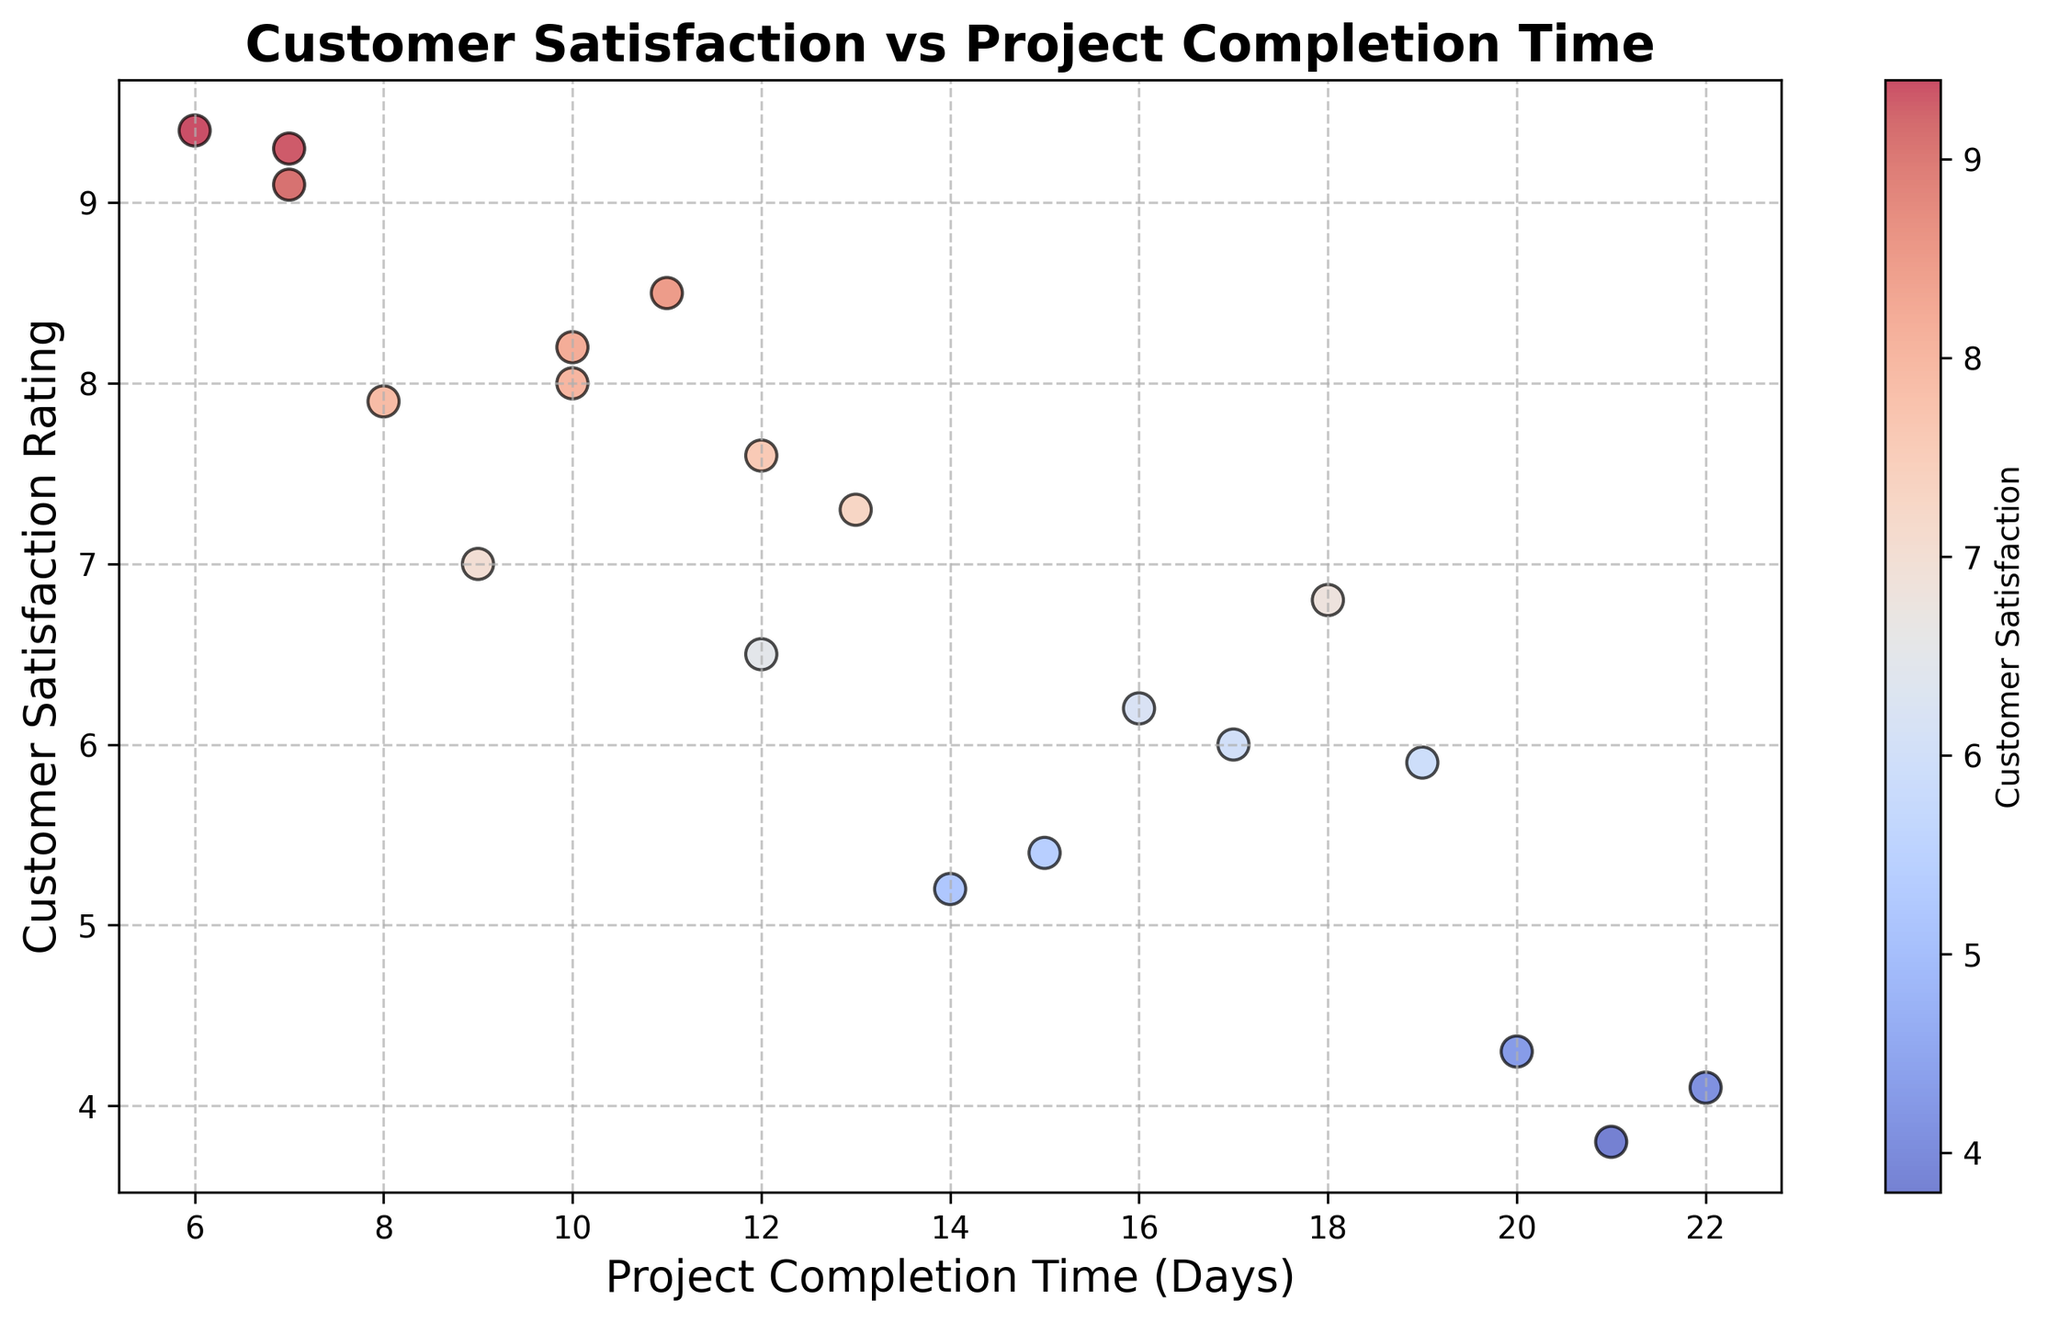What is the highest customer satisfaction rating on the chart? The highest point on the y-axis represents the maximum customer satisfaction rating. The point reaching the highest position presents 9.4
Answer: 9.4 Which project completion time has the lowest customer satisfaction rating? The data point closest to the bottom of the y-axis reflects the lowest customer satisfaction rating. The point is at a completion time of 21 days, corresponding to a rating of 3.8
Answer: 21 days Is there a correlation between project completion time and customer satisfaction rating? Visually inspect the spread and trend of the data points. A downward trend indicates a negative correlation, meaning longer project times generally result in lower satisfaction ratings.
Answer: Negative correlation Which project has the highest satisfaction rating achieved in under 10 days? Identify points where the x-axis (completion time) is less than 10 and find the highest point on the y-axis within this range. The point at 6 days correlates with the highest rating of 9.4
Answer: 9.4 Compare the rating for projects completed in 12 days and those completed in 15 days. Identify data points for both 12 and 15 days, then compare their y-axis positions. Projects at 12 days have satisfaction ratings of 6.5 and 7.6, and the projects at 15 days have a rating of 5.4. 6.5 and 7.6 are both higher than 5.4.
Answer: Projects at 12 days are higher What is the average customer satisfaction rating for projects completed within 10 days? Identify points with completion times ≤10 days and average their ratings: (8.2 + 7.9 + 9.1 + 8.5) / 4 = 33.7 / 4 = 8.425
Answer: 8.425 Count the number of projects that have a rating above 8.0 Identify all points whose y-values (customer satisfaction rating) are greater than 8.0. There are four such points (8.2, 9.1, 8.5, 9.4, and 9.3)
Answer: 5 Which project has the least satisfaction rating but completed in less than 20 days? Look for the lowest point within the x-axis range of less than 20 days. The point at 20 days does not fit ≤20 days criteria; hence the point at 15 days with a 5.4 rating is the lowest
Answer: 15 days What rating corresponds to the project completed in the shortest time? Look for the point at the smallest value on the x-axis, corresponding to the project completed in the least time, which is 6 days and has a satisfaction rating of 9.4
Answer: 9.4 